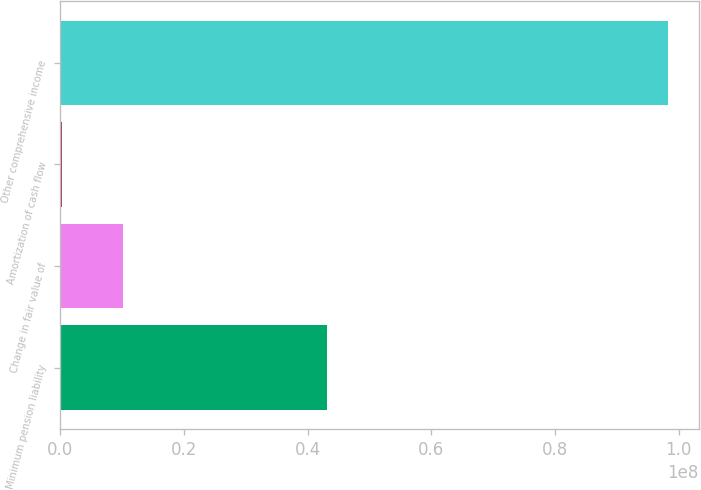Convert chart to OTSL. <chart><loc_0><loc_0><loc_500><loc_500><bar_chart><fcel>Minimum pension liability<fcel>Change in fair value of<fcel>Amortization of cash flow<fcel>Other comprehensive income<nl><fcel>4.318e+07<fcel>1.01292e+07<fcel>333000<fcel>9.8295e+07<nl></chart> 